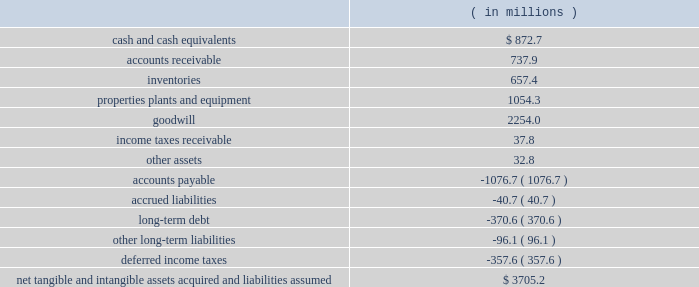Intangibles 2014 goodwill and other : testing goodwill for impairment in september 2011 , an accounting standard update was issued that allows entities an option to first assess qualitative factors to determine whether it is necessary to perform the two-step quantitative goodwill impairment test .
This standard is effective for annual and interim goodwill impairment testing beginning january 1 , 2012 .
This standard will not have an impact on our financial condition , results of operations and cash flows .
Note 2 : merger and acquisitions holly - frontier merger on february 21 , 2011 , we entered into a merger agreement providing for a 201cmerger of equals 201d business combination between us and frontier for purposes of creating a more diversified company having a broader geographic sales footprint , stronger financial position and to create a more efficient corporate overhead structure , while also realizing synergies and promoting accretion to earnings per share .
The legacy frontier business operations consist of crude oil refining and the wholesale marketing of refined petroleum products produced at the el dorado and cheyenne refineries and serve markets in the rocky mountain and plains states regions of the united states .
On july 1 , 2011 , north acquisition , inc. , a direct wholly-owned subsidiary of holly , merged with and into frontier , with frontier surviving as a wholly-owned subsidiary of holly .
Concurrent with the merger , we changed our name to hollyfrontier corporation and changed the ticker symbol for our common stock traded on the new york stock exchange to 201chfc . 201d subsequent to the merger and following approval by the post-closing board of directors of hollyfrontier , frontier merged with and into hollyfrontier , with hollyfrontier continuing as the surviving corporation .
In accordance with the merger agreement , we issued 102.8 million shares of hollyfrontier common stock in exchange for outstanding shares of frontier common stock to former frontier stockholders .
Each outstanding share of frontier common stock was converted into 0.4811 shares of hollyfrontier common stock with any fractional shares paid in cash .
The aggregate consideration paid in stock in connection with the merger was $ 3.7 billion .
This is based on our july 1 , 2011 market closing price of $ 35.93 and includes a portion of the fair value of the outstanding equity-based awards assumed from frontier that relates to pre-merger services .
The number of shares issued in connection with our merger with frontier and the closing market price of our common stock at july 1 , 2011 have been adjusted to reflect the two-for-one stock split on august 31 , 2011 .
The merger has been accounted for using the acquisition method of accounting with holly being considered the acquirer of frontier for accounting purposes .
Therefore , the purchase price was allocated to the fair value of the acquired assets and assumed liabilities at the acquisition date , with the excess purchase price being recorded as goodwill .
The goodwill resulting from the merger is primarily due to the favorable location of the acquired refining facilities and the expected synergies to be gained from our combined business operations .
Goodwill related to this merger is not deductible for income tax purposes .
The table summarizes our fair value estimates of the frontier assets and liabilities recognized upon our merger on july 1 , 2011: .

What was the quick ratio in july 2011 based on frontier assets and liabilities? 
Computations: ((872.7 + 737.9) / (40.7 + 1076.7))
Answer: 1.44138. 